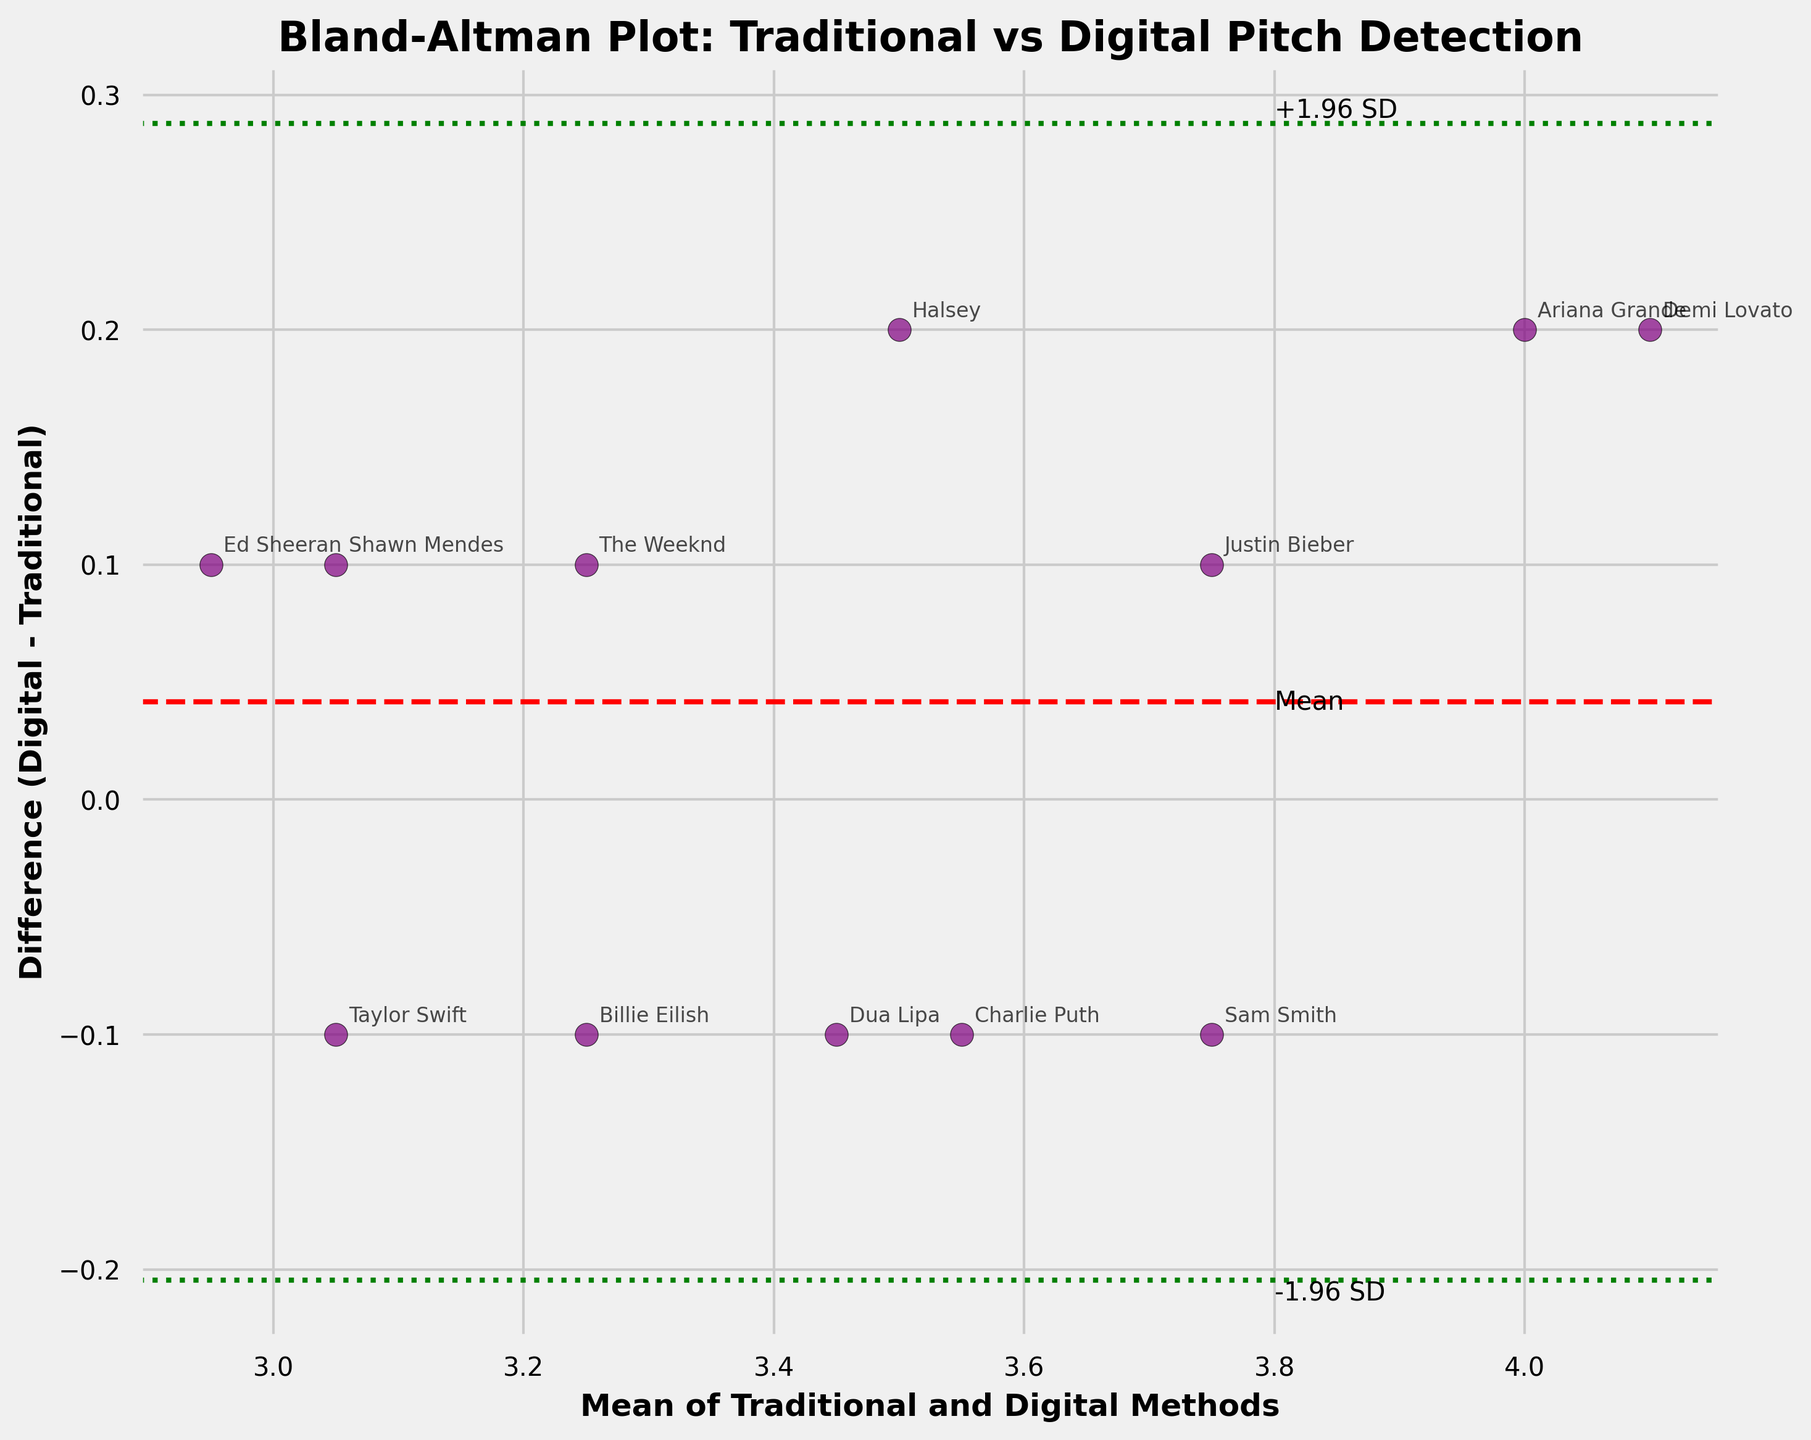How many data points are shown in the plot? The data points correspond to the different artists listed. Since we have 12 rows in the data, there are 12 data points in the plot.
Answer: 12 What is the title of the plot? The title of the plot is prominently displayed at the top. It reads "Bland-Altman Plot: Traditional vs Digital Pitch Detection".
Answer: Bland-Altman Plot: Traditional vs Digital Pitch Detection Which variable is represented on the x-axis? The x-axis label provides this information. It states "Mean of Traditional and Digital Methods".
Answer: Mean of Traditional and Digital Methods Which variable is represented on the y-axis? The y-axis label indicates it represents "Difference (Digital - Traditional)".
Answer: Difference (Digital - Traditional) What is the color and shape used for the data points? By examining the plot, the data points are purple circles with a black edge.
Answer: Purple circles with a black edge What is the mean difference between the traditional and digital methods? The mean difference is represented by the red dashed horizontal line. The label "Mean" is also placed near this line.
Answer: 0 Which artist has the largest positive difference between traditional and digital methods? By checking the annotations and the dispersal of points, Ariana Grande, Halsey, and Demi Lovato lie at the highest positive differences.
Answer: Halsey, Ariana Grande, Demi Lovato What are the upper and lower limits shown by the green dashed lines? The green dashed lines represent mean ± 1.96 * standard deviation. By looking at their labels and positions, the upper limit is +1.96 SD and the lower limit is -1.96 SD.
Answer: Upper: 0.19, Lower: -0.19 How many artists have a negative difference between the traditional and digital methods? To ascertain this, count the data points below the zero horizontal line.
Answer: 6 Is there any artist with exactly zero difference between traditional and digital methods? Check whether any data point lies exactly on the zero horizontal line.
Answer: No 